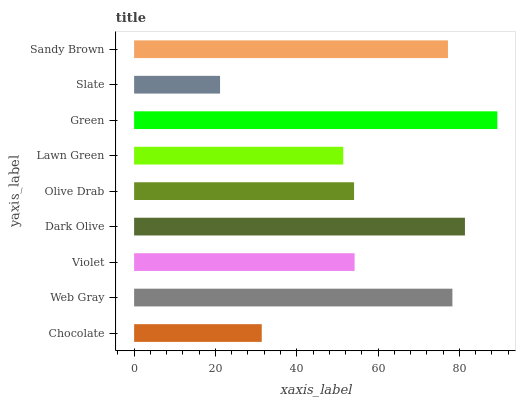Is Slate the minimum?
Answer yes or no. Yes. Is Green the maximum?
Answer yes or no. Yes. Is Web Gray the minimum?
Answer yes or no. No. Is Web Gray the maximum?
Answer yes or no. No. Is Web Gray greater than Chocolate?
Answer yes or no. Yes. Is Chocolate less than Web Gray?
Answer yes or no. Yes. Is Chocolate greater than Web Gray?
Answer yes or no. No. Is Web Gray less than Chocolate?
Answer yes or no. No. Is Violet the high median?
Answer yes or no. Yes. Is Violet the low median?
Answer yes or no. Yes. Is Chocolate the high median?
Answer yes or no. No. Is Sandy Brown the low median?
Answer yes or no. No. 